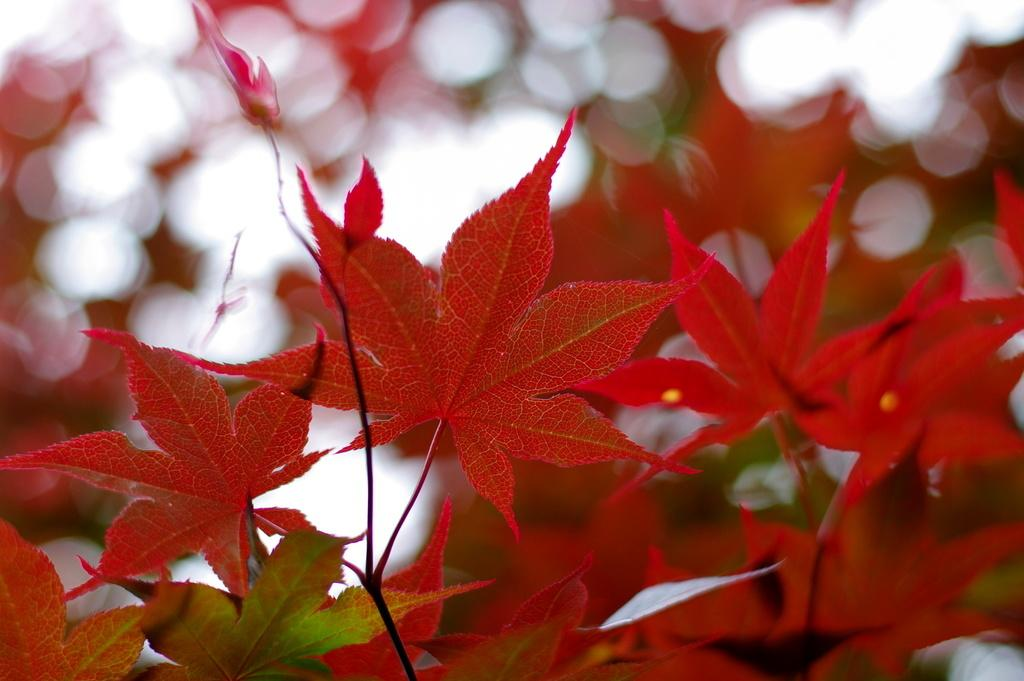What is the main subject of the image? The main subject of the image is a group of leaves from a tree. Can you describe the leaves in the image? The leaves are likely green and come from a tree, as they are a group of leaves. What might be the purpose of the image? The purpose of the image could be to showcase the beauty or detail of the leaves, or to document the tree they came from. What type of mine can be seen in the background of the image? There is no mine present in the image; it only features a group of leaves from a tree. 